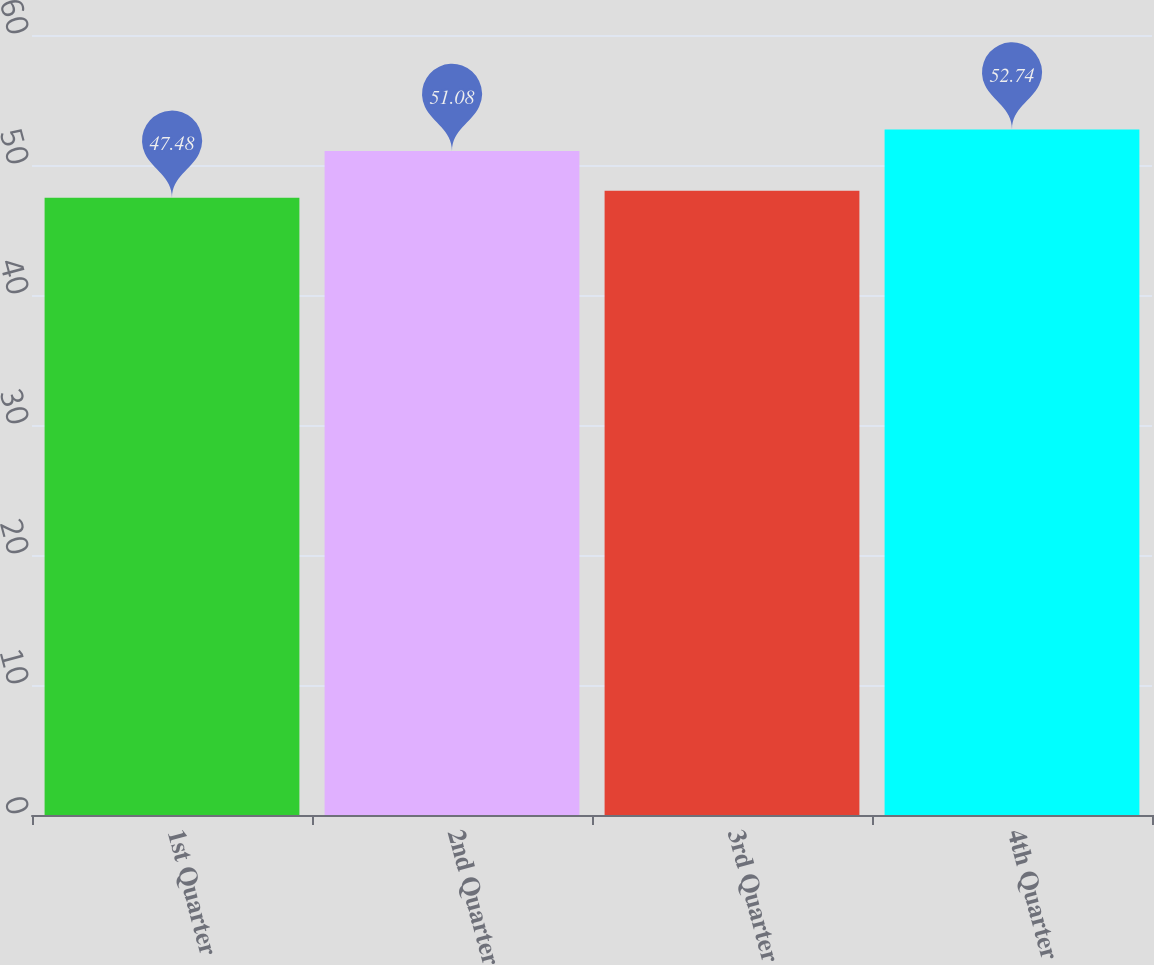Convert chart to OTSL. <chart><loc_0><loc_0><loc_500><loc_500><bar_chart><fcel>1st Quarter<fcel>2nd Quarter<fcel>3rd Quarter<fcel>4th Quarter<nl><fcel>47.48<fcel>51.08<fcel>48.01<fcel>52.74<nl></chart> 